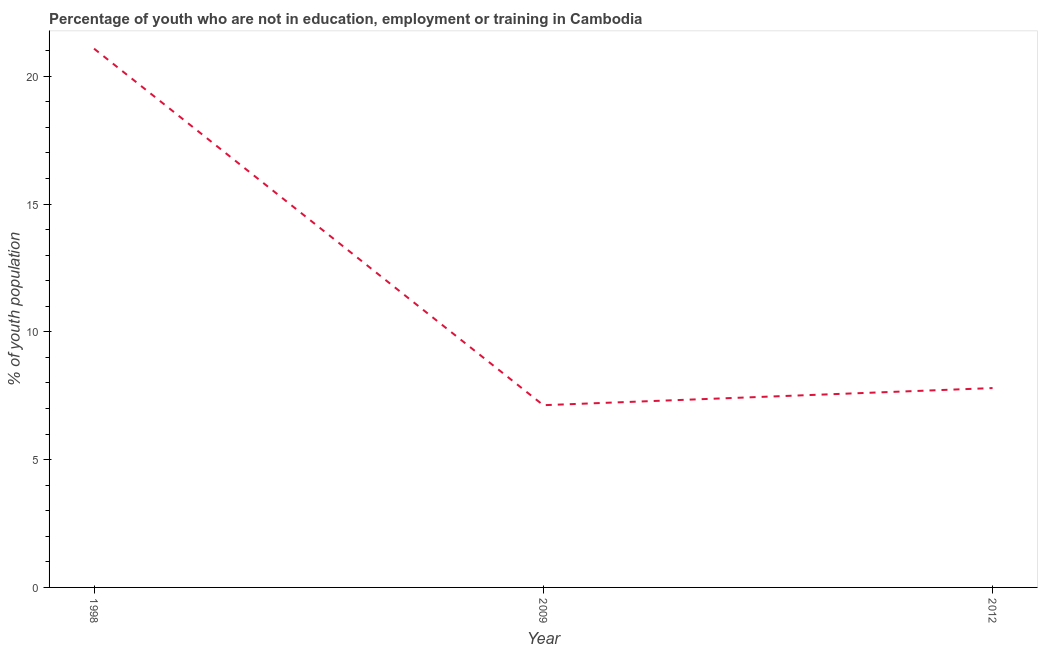What is the unemployed youth population in 2012?
Make the answer very short. 7.8. Across all years, what is the maximum unemployed youth population?
Give a very brief answer. 21.08. Across all years, what is the minimum unemployed youth population?
Give a very brief answer. 7.13. What is the sum of the unemployed youth population?
Your answer should be compact. 36.01. What is the difference between the unemployed youth population in 2009 and 2012?
Offer a very short reply. -0.67. What is the average unemployed youth population per year?
Offer a very short reply. 12. What is the median unemployed youth population?
Offer a terse response. 7.8. Do a majority of the years between 1998 and 2009 (inclusive) have unemployed youth population greater than 4 %?
Give a very brief answer. Yes. What is the ratio of the unemployed youth population in 1998 to that in 2012?
Offer a very short reply. 2.7. Is the difference between the unemployed youth population in 1998 and 2009 greater than the difference between any two years?
Your response must be concise. Yes. What is the difference between the highest and the second highest unemployed youth population?
Give a very brief answer. 13.28. What is the difference between the highest and the lowest unemployed youth population?
Provide a succinct answer. 13.95. How many lines are there?
Provide a short and direct response. 1. How many years are there in the graph?
Make the answer very short. 3. Are the values on the major ticks of Y-axis written in scientific E-notation?
Offer a terse response. No. What is the title of the graph?
Your answer should be very brief. Percentage of youth who are not in education, employment or training in Cambodia. What is the label or title of the X-axis?
Your answer should be compact. Year. What is the label or title of the Y-axis?
Your answer should be very brief. % of youth population. What is the % of youth population in 1998?
Your answer should be very brief. 21.08. What is the % of youth population in 2009?
Make the answer very short. 7.13. What is the % of youth population of 2012?
Offer a terse response. 7.8. What is the difference between the % of youth population in 1998 and 2009?
Give a very brief answer. 13.95. What is the difference between the % of youth population in 1998 and 2012?
Your answer should be compact. 13.28. What is the difference between the % of youth population in 2009 and 2012?
Provide a succinct answer. -0.67. What is the ratio of the % of youth population in 1998 to that in 2009?
Your answer should be very brief. 2.96. What is the ratio of the % of youth population in 1998 to that in 2012?
Your answer should be very brief. 2.7. What is the ratio of the % of youth population in 2009 to that in 2012?
Your response must be concise. 0.91. 